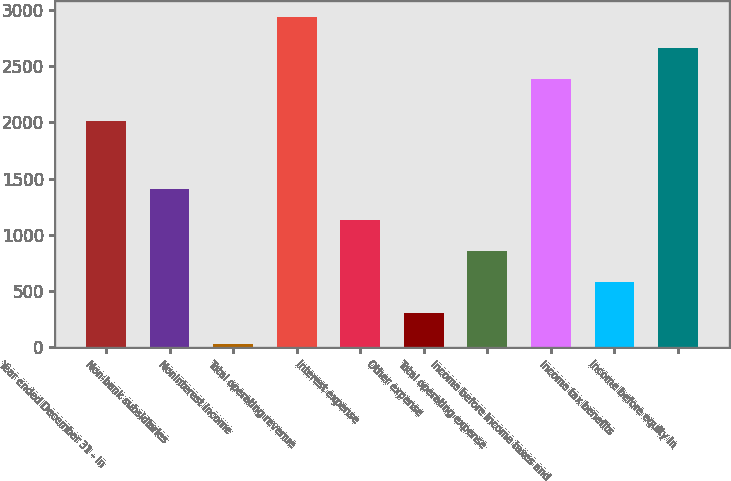<chart> <loc_0><loc_0><loc_500><loc_500><bar_chart><fcel>Year ended December 31 - in<fcel>Non-bank subsidiaries<fcel>Noninterest income<fcel>Total operating revenue<fcel>Interest expense<fcel>Other expense<fcel>Total operating expense<fcel>Income before income taxes and<fcel>Income tax benefits<fcel>Income before equity in<nl><fcel>2010<fcel>1404.5<fcel>27<fcel>2936<fcel>1129<fcel>302.5<fcel>853.5<fcel>2385<fcel>578<fcel>2660.5<nl></chart> 